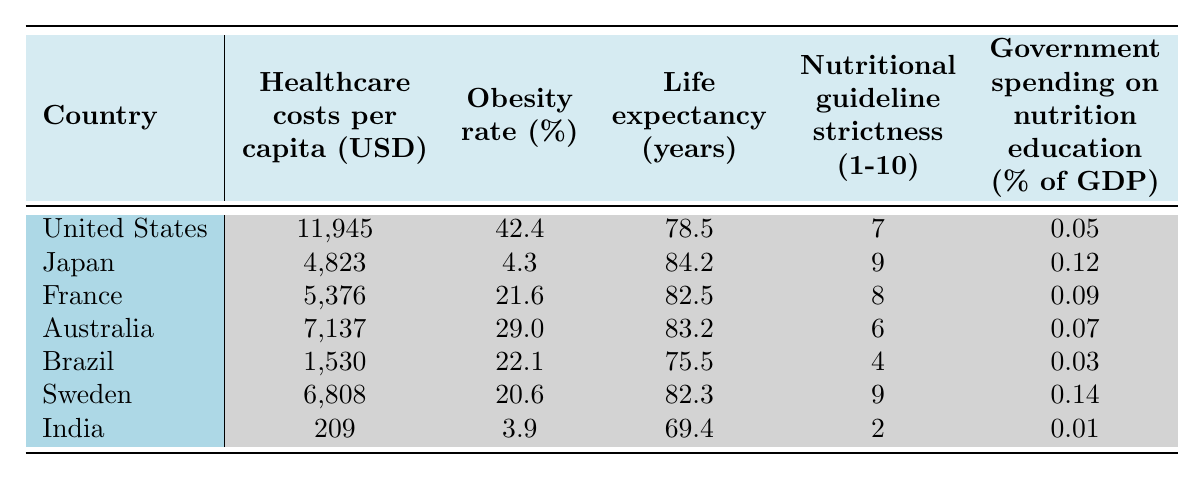What is the highest healthcare cost per capita among the listed countries? The highest healthcare cost per capita is found in the United States, which has a value of 11,945 USD.
Answer: 11,945 USD Which country has the lowest obesity rate? India has the lowest obesity rate at 3.9%.
Answer: 3.9% What is the life expectancy of Japan? Japan's life expectancy is noted as 84.2 years according to the table.
Answer: 84.2 years What is the nutritional guideline strictness of France? France has a nutritional guideline strictness rated at 8.
Answer: 8 What is the average obesity rate of the countries listed? The total obesity rates add up to 144.3%, divided by 7 countries gives an average of approximately 20.6%.
Answer: 20.6% Do countries with higher nutritional guideline strictness tend to have lower obesity rates? Analyzing the data: Japan (strictness 9, obesity 4.3%), France (8, 21.6%), Sweden (9, 20.6%), Australia (6, 29.0%), and the U.S. (7, 42.4%) suggests that higher strictness generally correlates with lower obesity rates.
Answer: Yes Which country spends the least percentage of GDP on nutrition education? Brazil spends the least at 0.03% of GDP on nutrition education.
Answer: 0.03% What is the difference in healthcare costs per capita between the United States and India? Subtracting India's healthcare cost (209 USD) from the United States' (11,945 USD) gives 11,736 USD.
Answer: 11,736 USD Which country has both a higher life expectancy and stricter nutritional guidelines than the United States? Japan has a life expectancy of 84.2 years and a nutritional guideline strictness of 9, both higher than those of the U.S.
Answer: Japan If the government spending on nutrition education in Sweden is 0.14%, how does it compare to Brazil's 0.03%? The difference is 0.14% - 0.03% = 0.11%, showing Sweden spends more on nutrition education.
Answer: 0.11% more 